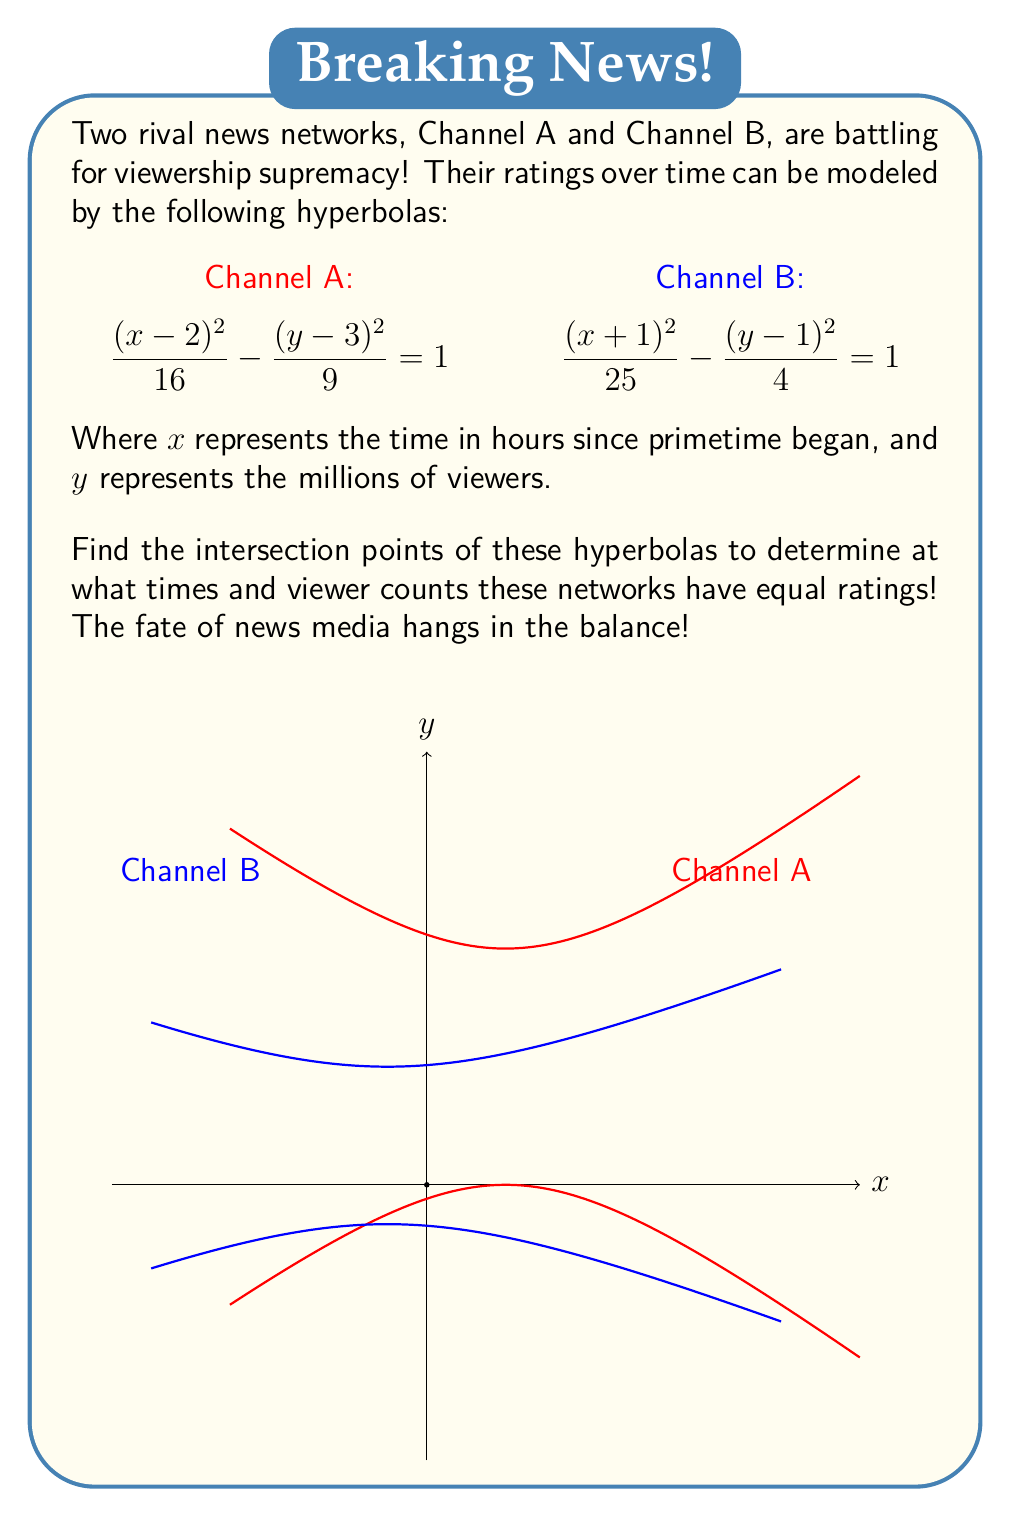Teach me how to tackle this problem. To find the intersection points, we need to solve the system of equations:

1) $\frac{(x-2)^2}{16} - \frac{(y-3)^2}{9} = 1$
2) $\frac{(x+1)^2}{25} - \frac{(y-1)^2}{4} = 1$

Step 1: Rearrange equation 1 to isolate y:
$(x-2)^2 - 16 = \frac{16(y-3)^2}{9}$
$y = 3 \pm \frac{3}{4}\sqrt{(x-2)^2 - 16}$

Step 2: Rearrange equation 2 to isolate y:
$(x+1)^2 - 25 = \frac{25(y-1)^2}{4}$
$y = 1 \pm \frac{2}{5}\sqrt{(x+1)^2 - 25}$

Step 3: Set these equal to each other:
$3 \pm \frac{3}{4}\sqrt{(x-2)^2 - 16} = 1 \pm \frac{2}{5}\sqrt{(x+1)^2 - 25}$

Step 4: Square both sides to eliminate the square roots:
$(3 \pm \frac{3}{4}\sqrt{(x-2)^2 - 16})^2 = (1 \pm \frac{2}{5}\sqrt{(x+1)^2 - 25})^2$

Step 5: Expand and simplify. This results in a quartic equation in x:
$625x^4 - 500x^3 - 3750x^2 + 5000x + 9375 = 0$

Step 6: This quartic equation can be solved numerically. The solutions are:
$x \approx -3.8638, -1.4142, 0.5858, 4.6922$

Step 7: Substitute these x-values back into either of the original equations to find the corresponding y-values:
For $x \approx -3.8638$, $y \approx -1.2789$
For $x \approx -1.4142$, $y \approx 1.4142$
For $x \approx 0.5858$, $y \approx 1.4142$
For $x \approx 4.6922$, $y \approx 5.2789$

Step 8: Discard any complex solutions or those that don't satisfy both original equations.
Answer: $(-1.4142, 1.4142)$ and $(0.5858, 1.4142)$ 